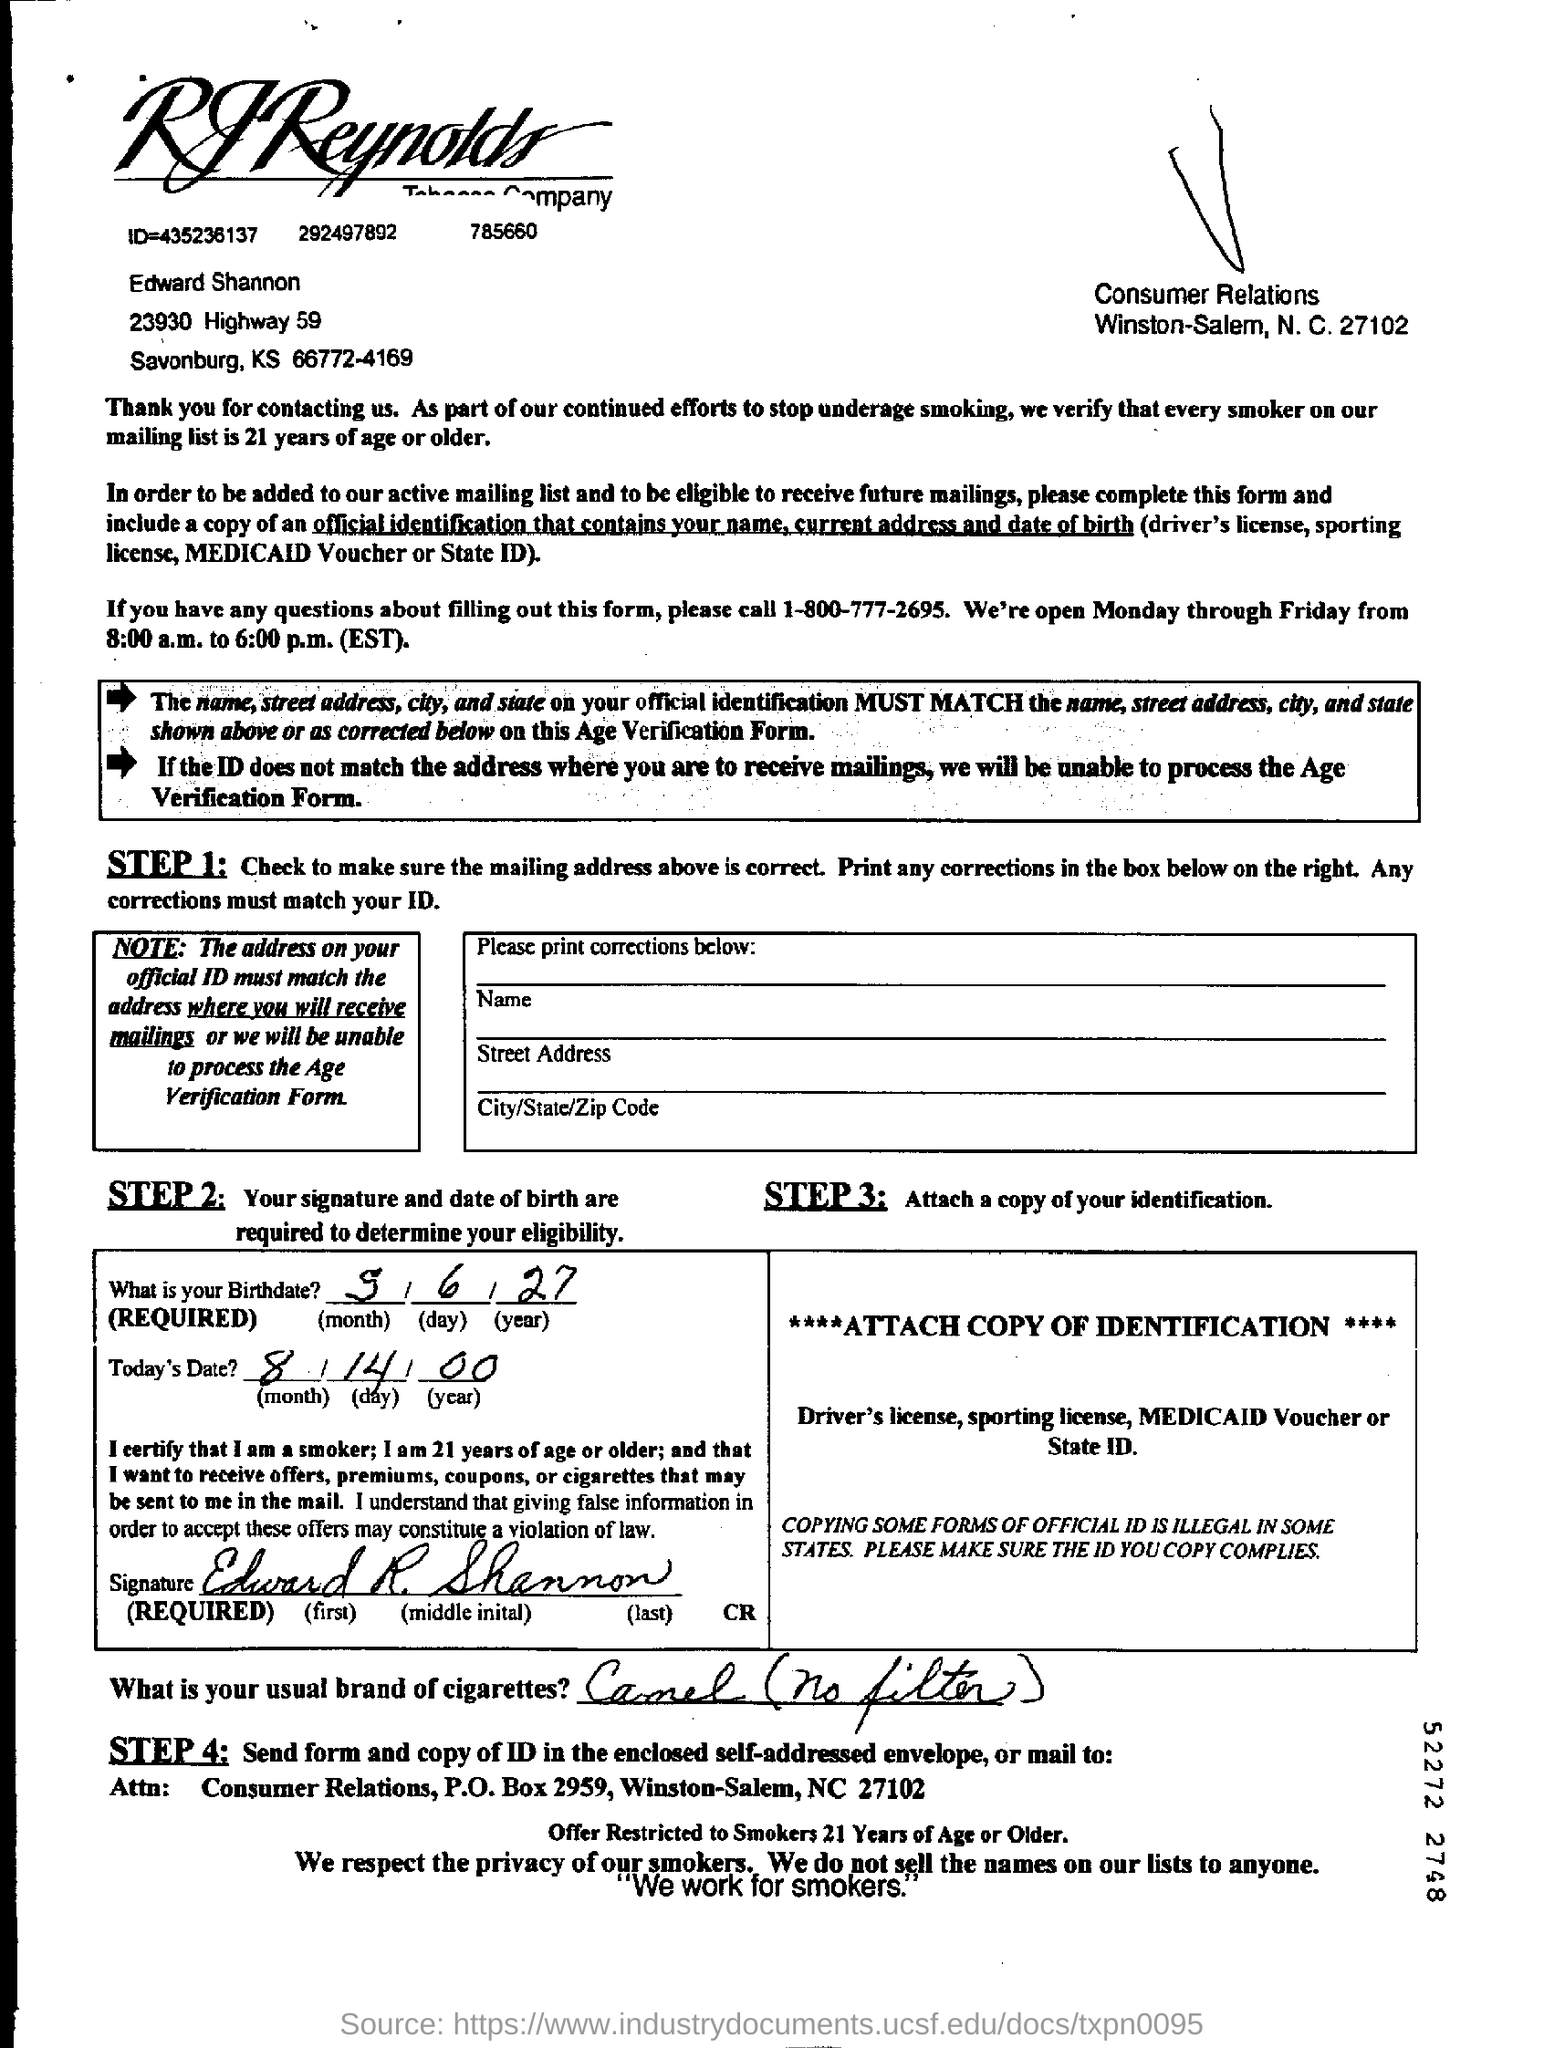Point out several critical features in this image. What is the date given? It is August 14, 2000. To inquire about questions related to filling out this form, please call number 1-800-777-2695. The signature of Edward R. Shannon is given. Edward typically smokes Camel cigarettes, which are unfiltered, as stated by the speaker in the given sentence. What is the birthdate given? May 6, 1927. 